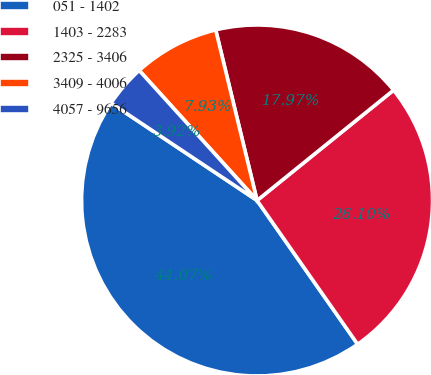<chart> <loc_0><loc_0><loc_500><loc_500><pie_chart><fcel>051 - 1402<fcel>1403 - 2283<fcel>2325 - 3406<fcel>3409 - 4006<fcel>4057 - 9656<nl><fcel>44.07%<fcel>26.1%<fcel>17.97%<fcel>7.93%<fcel>3.92%<nl></chart> 